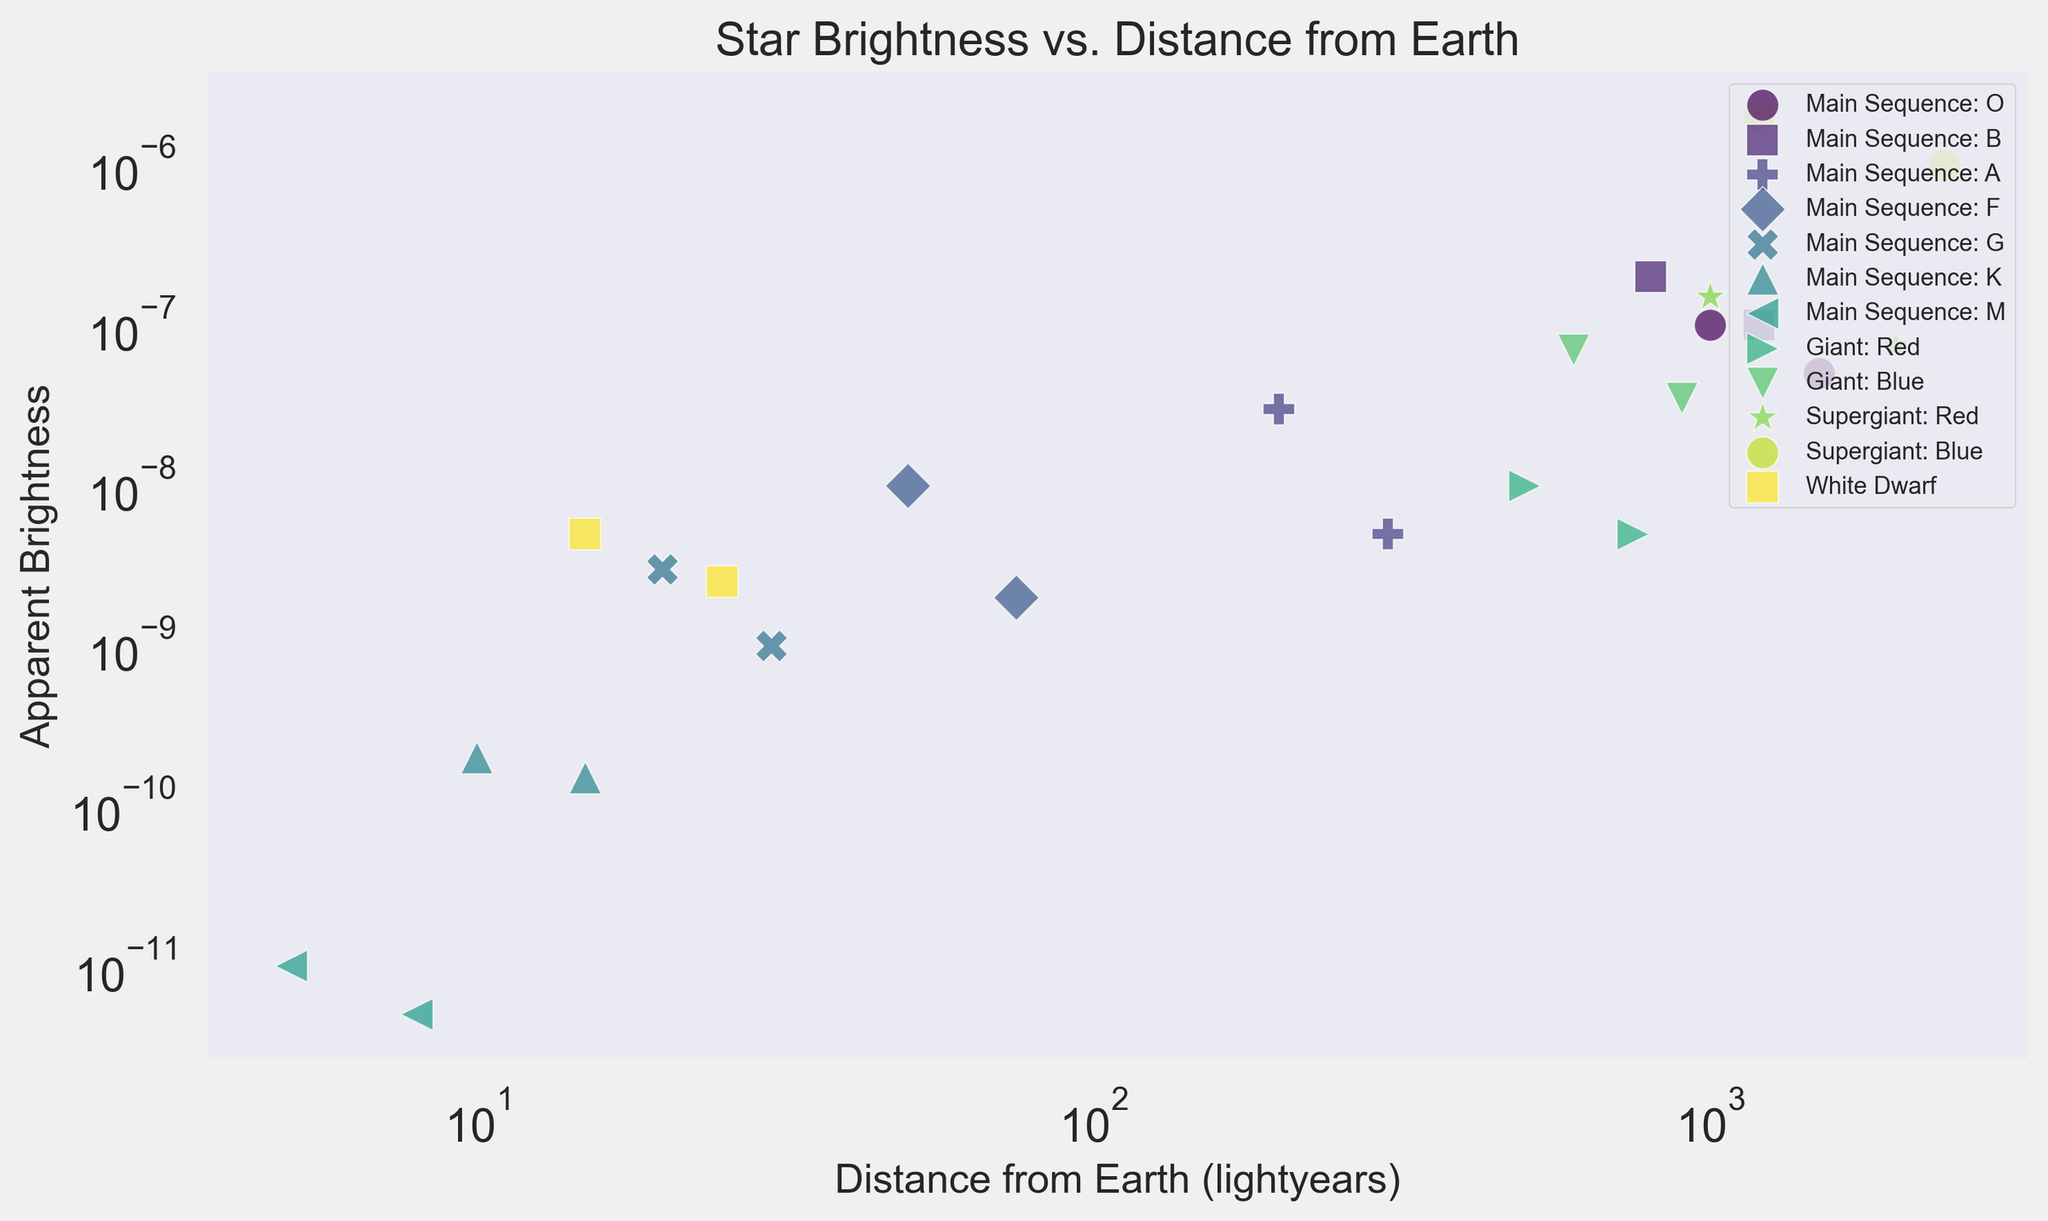Which star type is the brightest at 1000 lightyears? Locate the star type corresponding to the highest apparent brightness at the 1000 lightyears distance mark. "Supergiant: Red" star type has an apparent brightness of 1.5e-7 at this distance.
Answer: Supergiant: Red How does the brightness of Main Sequence: O stars compare between 1000 and 1500 lightyears? Check the apparent brightness of "Main Sequence: O" stars at 1000 lightyears (1.0e-7) and at 1500 lightyears (5.0e-8). The brightness decreases as the distance increases.
Answer: Decreases Which star type has the least apparent brightness and at what distance? Identify the data point with the smallest apparent brightness. "Main Sequence: M" star type has the least apparent brightness of 5.0e-12 at 8 lightyears.
Answer: Main Sequence: M, 8 lightyears What is the average apparent brightness of Main Sequence: A stars? Locate the apparent brightness values for "Main Sequence: A" stars (3.0e-8 and 5.0e-9). The average is calculated as (3.0e-8 + 5.0e-9) / 2 = 1.75e-8.
Answer: 1.75e-8 Are there any star types that have similar brightness at different distances? Compare the apparent brightness of stars at different distances. "Giant: Red" stars have brightnesses of 1.0e-8 and 5.0e-9 at 500 and 750 lightyears, respectively, they are relatively close in value.
Answer: Giant: Red Which star type has the highest apparent brightness, and at what distance? Identify the data point with the highest apparent brightness. "Supergiant: Blue" star type has the highest apparent brightness of 2.0e-6 at a distance of 1200 lightyears.
Answer: Supergiant: Blue, 1200 lightyears 